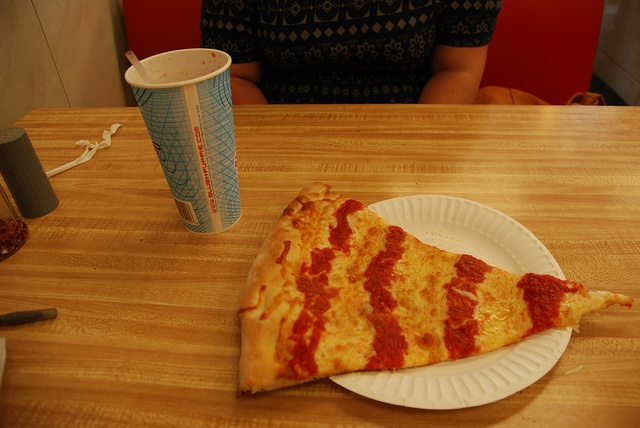Describe the objects in this image and their specific colors. I can see dining table in red, maroon, tan, and orange tones, pizza in maroon, red, and orange tones, people in maroon, black, and brown tones, cup in maroon, olive, and gray tones, and bench in maroon, black, and tan tones in this image. 